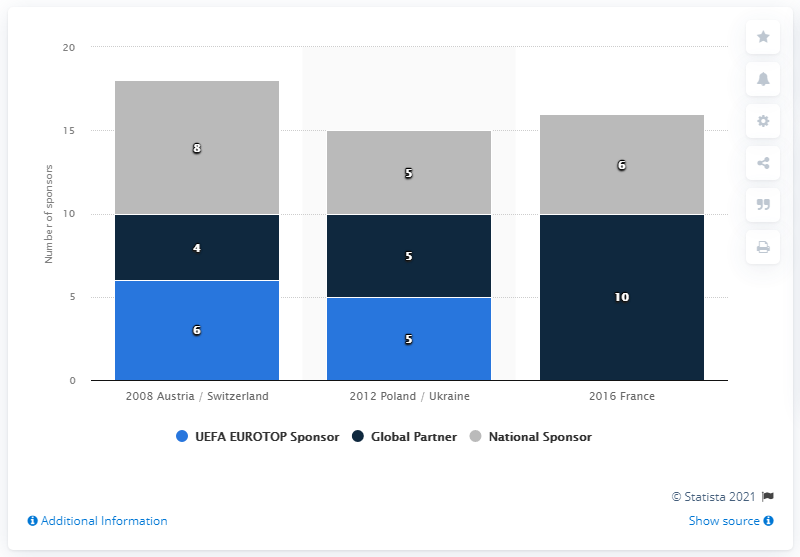Highlight a few significant elements in this photo. In 2016, France had the highest number of Global partner sponsors. In the year 2008, the sum total of global partners and national sponsors was 18. 